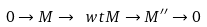Convert formula to latex. <formula><loc_0><loc_0><loc_500><loc_500>0 \to M \to \ w t M \to M ^ { \prime \prime } \to 0</formula> 